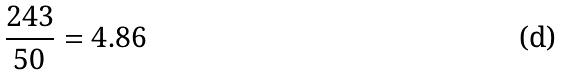<formula> <loc_0><loc_0><loc_500><loc_500>\frac { 2 4 3 } { 5 0 } = 4 . 8 6</formula> 